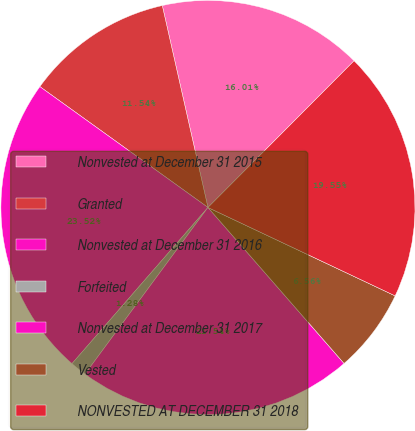Convert chart to OTSL. <chart><loc_0><loc_0><loc_500><loc_500><pie_chart><fcel>Nonvested at December 31 2015<fcel>Granted<fcel>Nonvested at December 31 2016<fcel>Forfeited<fcel>Nonvested at December 31 2017<fcel>Vested<fcel>NONVESTED AT DECEMBER 31 2018<nl><fcel>16.01%<fcel>11.54%<fcel>23.52%<fcel>1.28%<fcel>21.54%<fcel>6.56%<fcel>19.55%<nl></chart> 